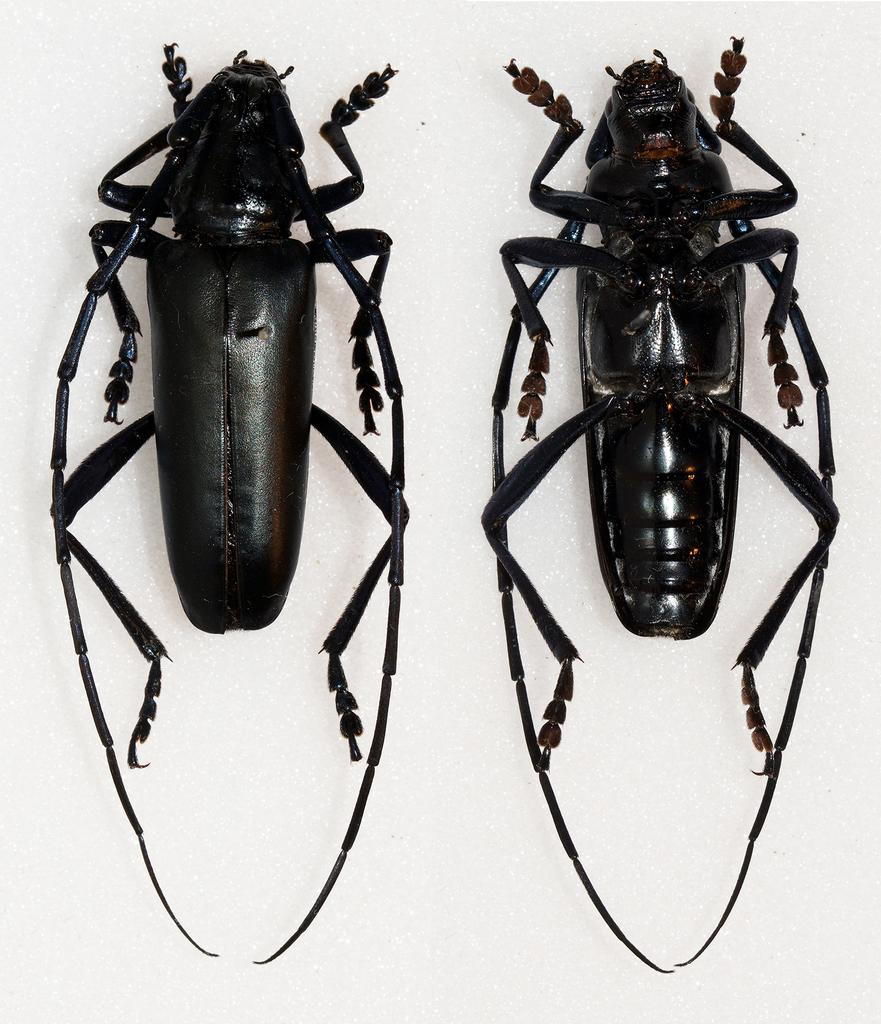What type of insects are present in the image? There are two cockroaches in the image. What color are the cockroaches? The cockroaches are black in color. What is the color of the background in the image? The background of the image is white. Can you see a giraffe drinking from a stream in the image? No, there is no giraffe or stream present in the image; it features two black cockroaches on a white background. 